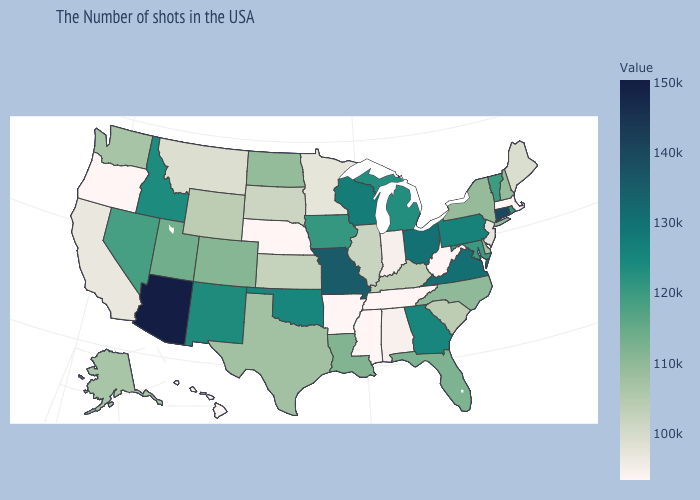Does Illinois have the lowest value in the USA?
Concise answer only. No. Does Colorado have a higher value than West Virginia?
Quick response, please. Yes. Does Georgia have the highest value in the South?
Short answer required. No. Among the states that border Wisconsin , does Illinois have the lowest value?
Short answer required. No. 